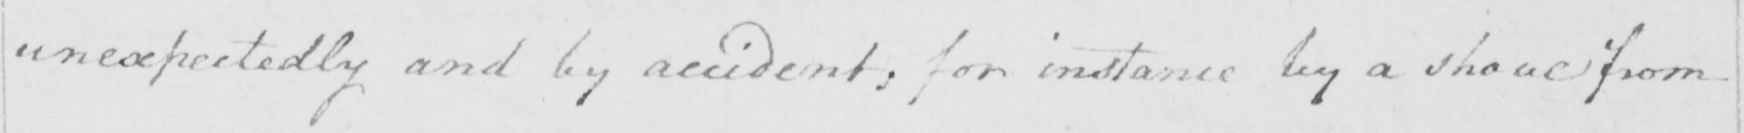What is written in this line of handwriting? unexpectedly and by accident , for instance by a shove from 